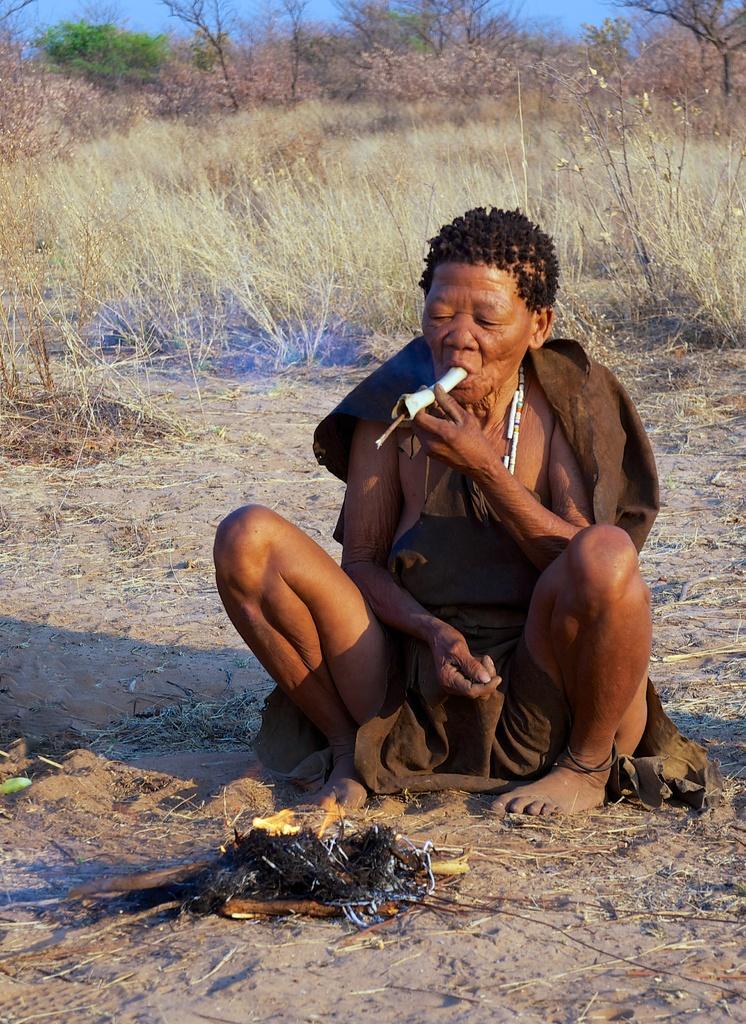Describe this image in one or two sentences. In this picture there is a person sitting and holding an object with mouth and hand. We can see sand and fire. In the background of the image we can see grass, trees and sky. 